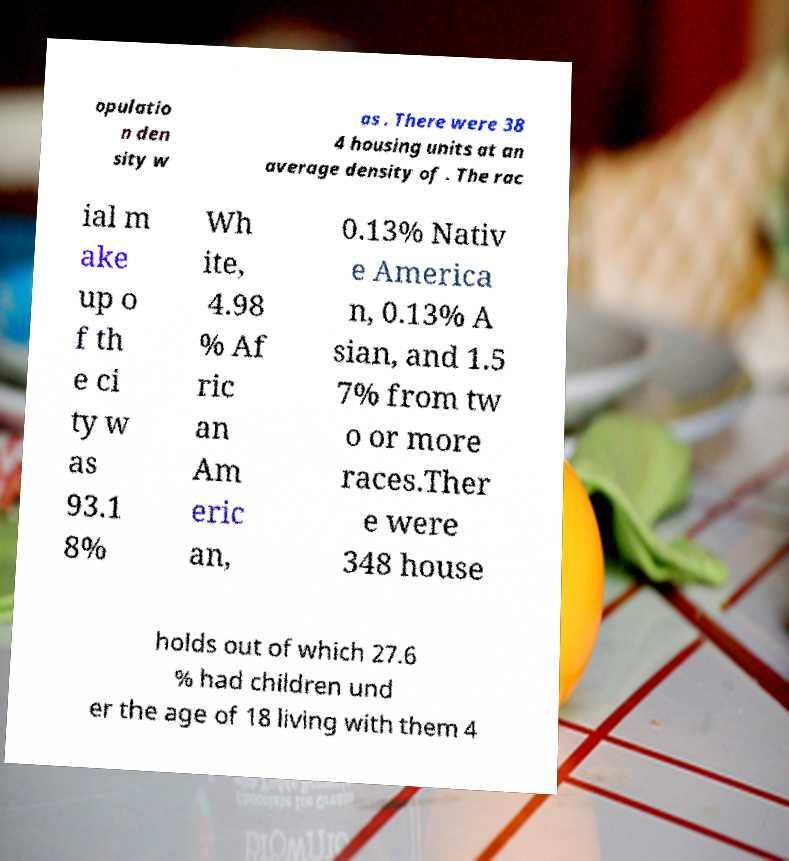Could you extract and type out the text from this image? opulatio n den sity w as . There were 38 4 housing units at an average density of . The rac ial m ake up o f th e ci ty w as 93.1 8% Wh ite, 4.98 % Af ric an Am eric an, 0.13% Nativ e America n, 0.13% A sian, and 1.5 7% from tw o or more races.Ther e were 348 house holds out of which 27.6 % had children und er the age of 18 living with them 4 